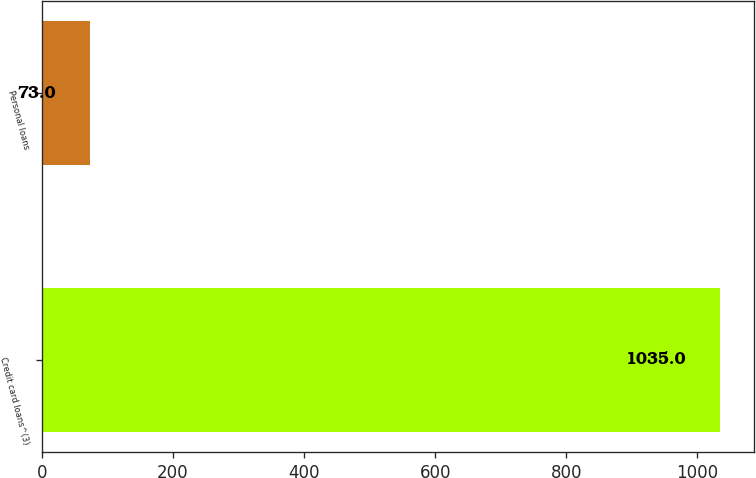<chart> <loc_0><loc_0><loc_500><loc_500><bar_chart><fcel>Credit card loans^(3)<fcel>Personal loans<nl><fcel>1035<fcel>73<nl></chart> 